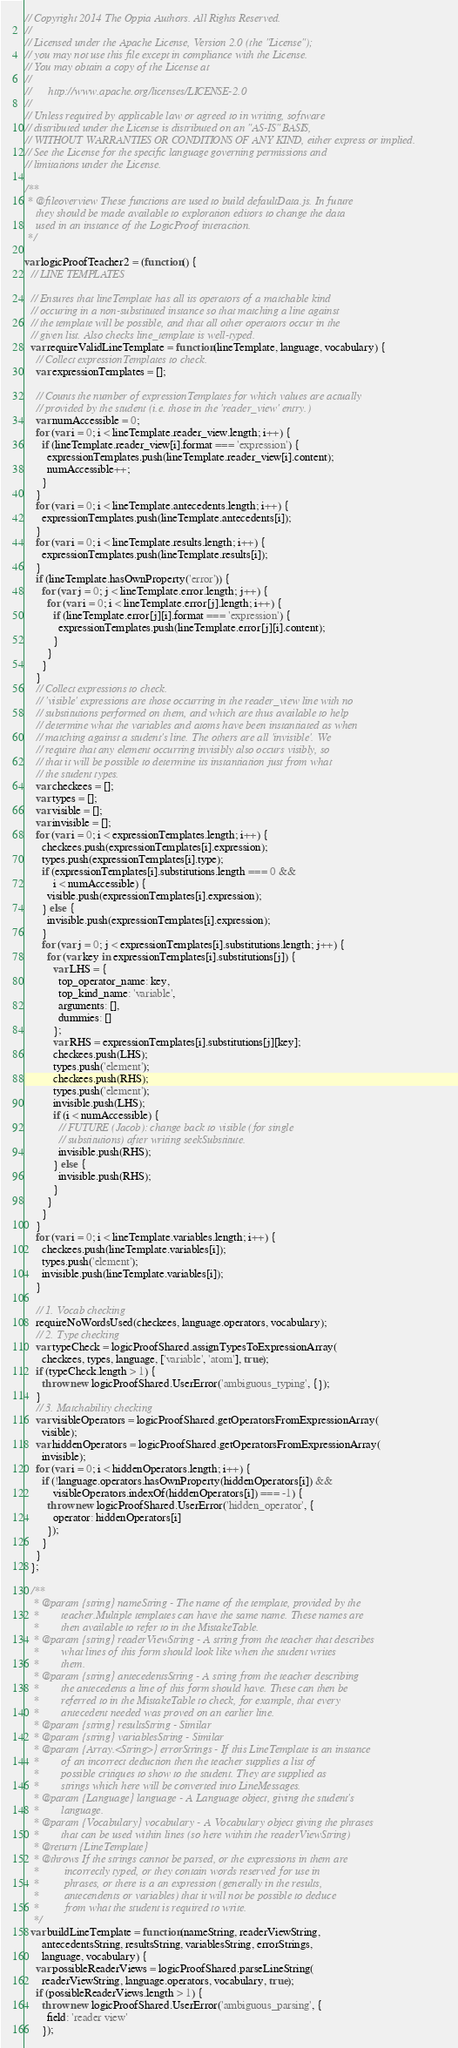<code> <loc_0><loc_0><loc_500><loc_500><_JavaScript_>// Copyright 2014 The Oppia Authors. All Rights Reserved.
//
// Licensed under the Apache License, Version 2.0 (the "License");
// you may not use this file except in compliance with the License.
// You may obtain a copy of the License at
//
//      http://www.apache.org/licenses/LICENSE-2.0
//
// Unless required by applicable law or agreed to in writing, software
// distributed under the License is distributed on an "AS-IS" BASIS,
// WITHOUT WARRANTIES OR CONDITIONS OF ANY KIND, either express or implied.
// See the License for the specific language governing permissions and
// limitations under the License.

/**
 * @fileoverview These functions are used to build defaultData.js. In future
    they should be made available to exploration editors to change the data
    used in an instance of the LogicProof interaction.
 */

var logicProofTeacher2 = (function() {
  // LINE TEMPLATES

  // Ensures that lineTemplate has all its operators of a matchable kind
  // occuring in a non-substituted instance so that matching a line against
  // the template will be possible, and that all other operators occur in the
  // given list. Also checks line_template is well-typed.
  var requireValidLineTemplate = function(lineTemplate, language, vocabulary) {
    // Collect expressionTemplates to check.
    var expressionTemplates = [];

    // Counts the number of expressionTemplates for which values are actually
    // provided by the student (i.e. those in the 'reader_view' entry.)
    var numAccessible = 0;
    for (var i = 0; i < lineTemplate.reader_view.length; i++) {
      if (lineTemplate.reader_view[i].format === 'expression') {
        expressionTemplates.push(lineTemplate.reader_view[i].content);
        numAccessible++;
      }
    }
    for (var i = 0; i < lineTemplate.antecedents.length; i++) {
      expressionTemplates.push(lineTemplate.antecedents[i]);
    }
    for (var i = 0; i < lineTemplate.results.length; i++) {
      expressionTemplates.push(lineTemplate.results[i]);
    }
    if (lineTemplate.hasOwnProperty('error')) {
      for (var j = 0; j < lineTemplate.error.length; j++) {
        for (var i = 0; i < lineTemplate.error[j].length; i++) {
          if (lineTemplate.error[j][i].format === 'expression') {
            expressionTemplates.push(lineTemplate.error[j][i].content);
          }
        }
      }
    }
    // Collect expressions to check.
    // 'visible' expressions are those occurring in the reader_view line with no
    // substitutions performed on them, and which are thus available to help
    // determine what the variables and atoms have been instantiated as when
    // matching against a student's line. The others are all 'invisible'. We
    // require that any element occurring invisibly also occurs visibly, so
    // that it will be possible to determine its instantiation just from what
    // the student types.
    var checkees = [];
    var types = [];
    var visible = [];
    var invisible = [];
    for (var i = 0; i < expressionTemplates.length; i++) {
      checkees.push(expressionTemplates[i].expression);
      types.push(expressionTemplates[i].type);
      if (expressionTemplates[i].substitutions.length === 0 &&
          i < numAccessible) {
        visible.push(expressionTemplates[i].expression);
      } else {
        invisible.push(expressionTemplates[i].expression);
      }
      for (var j = 0; j < expressionTemplates[i].substitutions.length; j++) {
        for (var key in expressionTemplates[i].substitutions[j]) {
          var LHS = {
            top_operator_name: key,
            top_kind_name: 'variable',
            arguments: [],
            dummies: []
          };
          var RHS = expressionTemplates[i].substitutions[j][key];
          checkees.push(LHS);
          types.push('element');
          checkees.push(RHS);
          types.push('element');
          invisible.push(LHS);
          if (i < numAccessible) {
            // FUTURE (Jacob): change back to visible (for single
            // substitutions) after writing seekSubstitute.
            invisible.push(RHS);
          } else {
            invisible.push(RHS);
          }
        }
      }
    }
    for (var i = 0; i < lineTemplate.variables.length; i++) {
      checkees.push(lineTemplate.variables[i]);
      types.push('element');
      invisible.push(lineTemplate.variables[i]);
    }

    // 1. Vocab checking
    requireNoWordsUsed(checkees, language.operators, vocabulary);
    // 2. Type checking
    var typeCheck = logicProofShared.assignTypesToExpressionArray(
      checkees, types, language, ['variable', 'atom'], true);
    if (typeCheck.length > 1) {
      throw new logicProofShared.UserError('ambiguous_typing', {});
    }
    // 3. Matchability checking
    var visibleOperators = logicProofShared.getOperatorsFromExpressionArray(
      visible);
    var hiddenOperators = logicProofShared.getOperatorsFromExpressionArray(
      invisible);
    for (var i = 0; i < hiddenOperators.length; i++) {
      if (!language.operators.hasOwnProperty(hiddenOperators[i]) &&
          visibleOperators.indexOf(hiddenOperators[i]) === -1) {
        throw new logicProofShared.UserError('hidden_operator', {
          operator: hiddenOperators[i]
        });
      }
    }
  };

  /**
   * @param {string} nameString - The name of the template, provided by the
   *        teacher.Multiple templates can have the same name. These names are
   *        then available to refer to in the MistakeTable.
   * @param {string} readerViewString - A string from the teacher that describes
   *        what lines of this form should look like when the student writes
   *        them.
   * @param {string} antecedentsString - A string from the teacher describing
   *        the antecedents a line of this form should have. These can then be
   *        referred to in the MistakeTable to check, for example, that every
   *        antecedent needed was proved on an earlier line.
   * @param {string} resultsString - Similar
   * @param {string} variablesString - Similar
   * @param {Array.<String>} errorStrings - If this LineTemplate is an instance
   *        of an incorrect deduction then the teacher supplies a list of
   *        possible critiques to show to the student. They are supplied as
   *        strings which here will be converted into LineMessages.
   * @param {Language} language - A Language object, giving the student's
   *        language.
   * @param {Vocabulary} vocabulary - A Vocabulary object giving the phrases
   *        that can be used within lines (so here within the readerViewString)
   * @return {LineTemplate}
   * @throws If the strings cannot be parsed, or the expressions in them are
   *         incorrectly typed, or they contain words reserved for use in
   *         phrases, or there is a an expression (generally in the results,
   *         antecendents or variables) that it will not be possible to deduce
   *         from what the student is required to write.
   */
  var buildLineTemplate = function(nameString, readerViewString,
      antecedentsString, resultsString, variablesString, errorStrings,
      language, vocabulary) {
    var possibleReaderViews = logicProofShared.parseLineString(
      readerViewString, language.operators, vocabulary, true);
    if (possibleReaderViews.length > 1) {
      throw new logicProofShared.UserError('ambiguous_parsing', {
        field: 'reader view'
      });</code> 